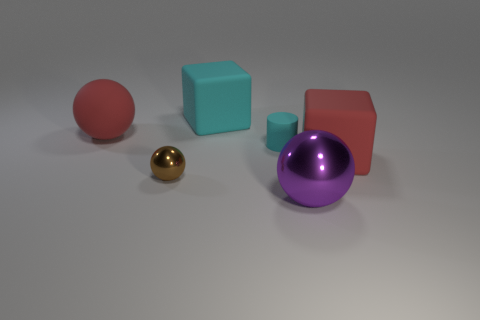Add 4 red matte cubes. How many objects exist? 10 Subtract all blocks. How many objects are left? 4 Subtract 0 blue cylinders. How many objects are left? 6 Subtract all small brown metallic objects. Subtract all large metal things. How many objects are left? 4 Add 1 purple metallic objects. How many purple metallic objects are left? 2 Add 6 small brown shiny balls. How many small brown shiny balls exist? 7 